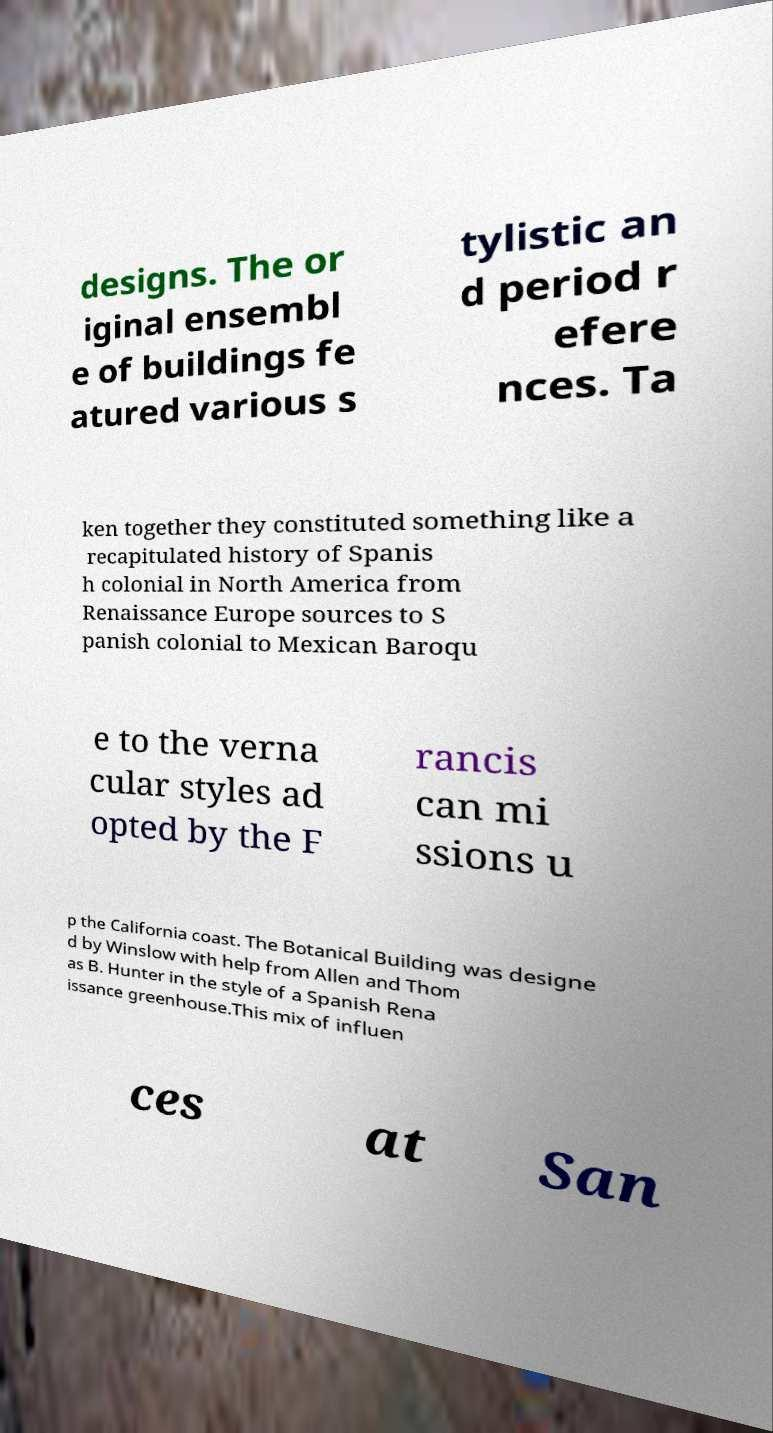Could you extract and type out the text from this image? designs. The or iginal ensembl e of buildings fe atured various s tylistic an d period r efere nces. Ta ken together they constituted something like a recapitulated history of Spanis h colonial in North America from Renaissance Europe sources to S panish colonial to Mexican Baroqu e to the verna cular styles ad opted by the F rancis can mi ssions u p the California coast. The Botanical Building was designe d by Winslow with help from Allen and Thom as B. Hunter in the style of a Spanish Rena issance greenhouse.This mix of influen ces at San 